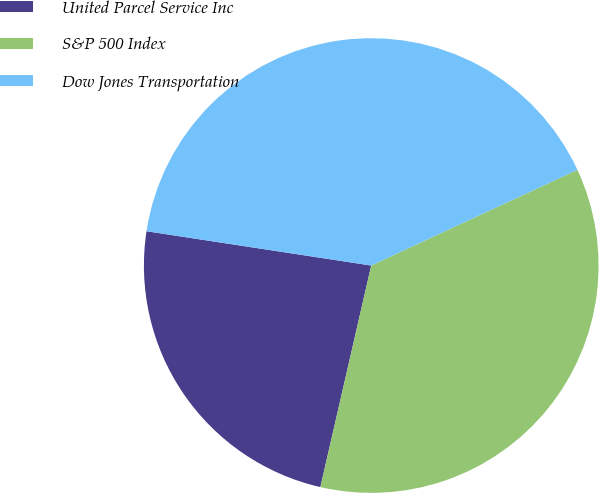<chart> <loc_0><loc_0><loc_500><loc_500><pie_chart><fcel>United Parcel Service Inc<fcel>S&P 500 Index<fcel>Dow Jones Transportation<nl><fcel>23.82%<fcel>35.51%<fcel>40.67%<nl></chart> 